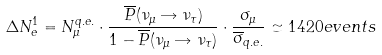<formula> <loc_0><loc_0><loc_500><loc_500>\Delta N _ { e } ^ { 1 } = N _ { \mu } ^ { q . e . } \cdot \frac { \overline { P } ( \nu _ { \mu } \rightarrow \nu _ { \tau } ) } { 1 - \overline { P } ( \nu _ { \mu } \rightarrow \nu _ { \tau } ) } \cdot \frac { \sigma _ { \mu } } { \overline { \sigma } _ { q . e . } } \simeq 1 4 2 0 e v e n t s</formula> 